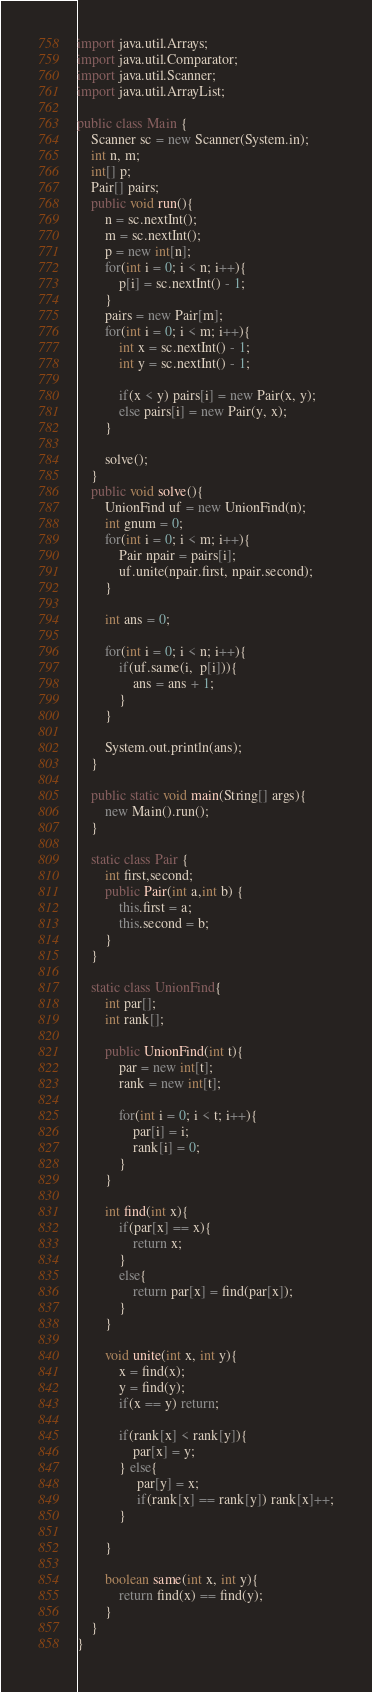Convert code to text. <code><loc_0><loc_0><loc_500><loc_500><_Java_>import java.util.Arrays;
import java.util.Comparator;
import java.util.Scanner;
import java.util.ArrayList;

public class Main {
	Scanner sc = new Scanner(System.in);
	int n, m;
	int[] p; 
	Pair[] pairs;
	public void run(){
		n = sc.nextInt();
		m = sc.nextInt();
		p = new int[n];
		for(int i = 0; i < n; i++){
			p[i] = sc.nextInt() - 1;
		}
		pairs = new Pair[m];
		for(int i = 0; i < m; i++){
			int x = sc.nextInt() - 1;
			int y = sc.nextInt() - 1;
			
			if(x < y) pairs[i] = new Pair(x, y);
			else pairs[i] = new Pair(y, x);
		}
		
		solve();
	}
	public void solve(){
		UnionFind uf = new UnionFind(n);
		int gnum = 0;
		for(int i = 0; i < m; i++){
			Pair npair = pairs[i];
			uf.unite(npair.first, npair.second);
		}
		
		int ans = 0;
		
		for(int i = 0; i < n; i++){
			if(uf.same(i,  p[i])){
				ans = ans + 1;
			}
		}
		
		System.out.println(ans);
	}
	
	public static void main(String[] args){
		new Main().run();
	}
	
	static class Pair {
        int first,second;
        public Pair(int a,int b) {
            this.first = a;
            this.second = b;
        }
    }	
	
	static class UnionFind{
		int par[];
		int rank[];
		
		public UnionFind(int t){
			par = new int[t];
			rank = new int[t];
			
			for(int i = 0; i < t; i++){
				par[i] = i;
				rank[i] = 0;
			}
		}
		
		int find(int x){
			if(par[x] == x){
				return x;
			}
			else{
				return par[x] = find(par[x]);
			}
		}
		
		void unite(int x, int y){
			x = find(x);
			y = find(y);
			if(x == y) return;
			
			if(rank[x] < rank[y]){
				par[x] = y;
			} else{
				 par[y] = x;
				 if(rank[x] == rank[y]) rank[x]++;
			}
			
		}
		
		boolean same(int x, int y){
			return find(x) == find(y);
		}
	}
}
</code> 